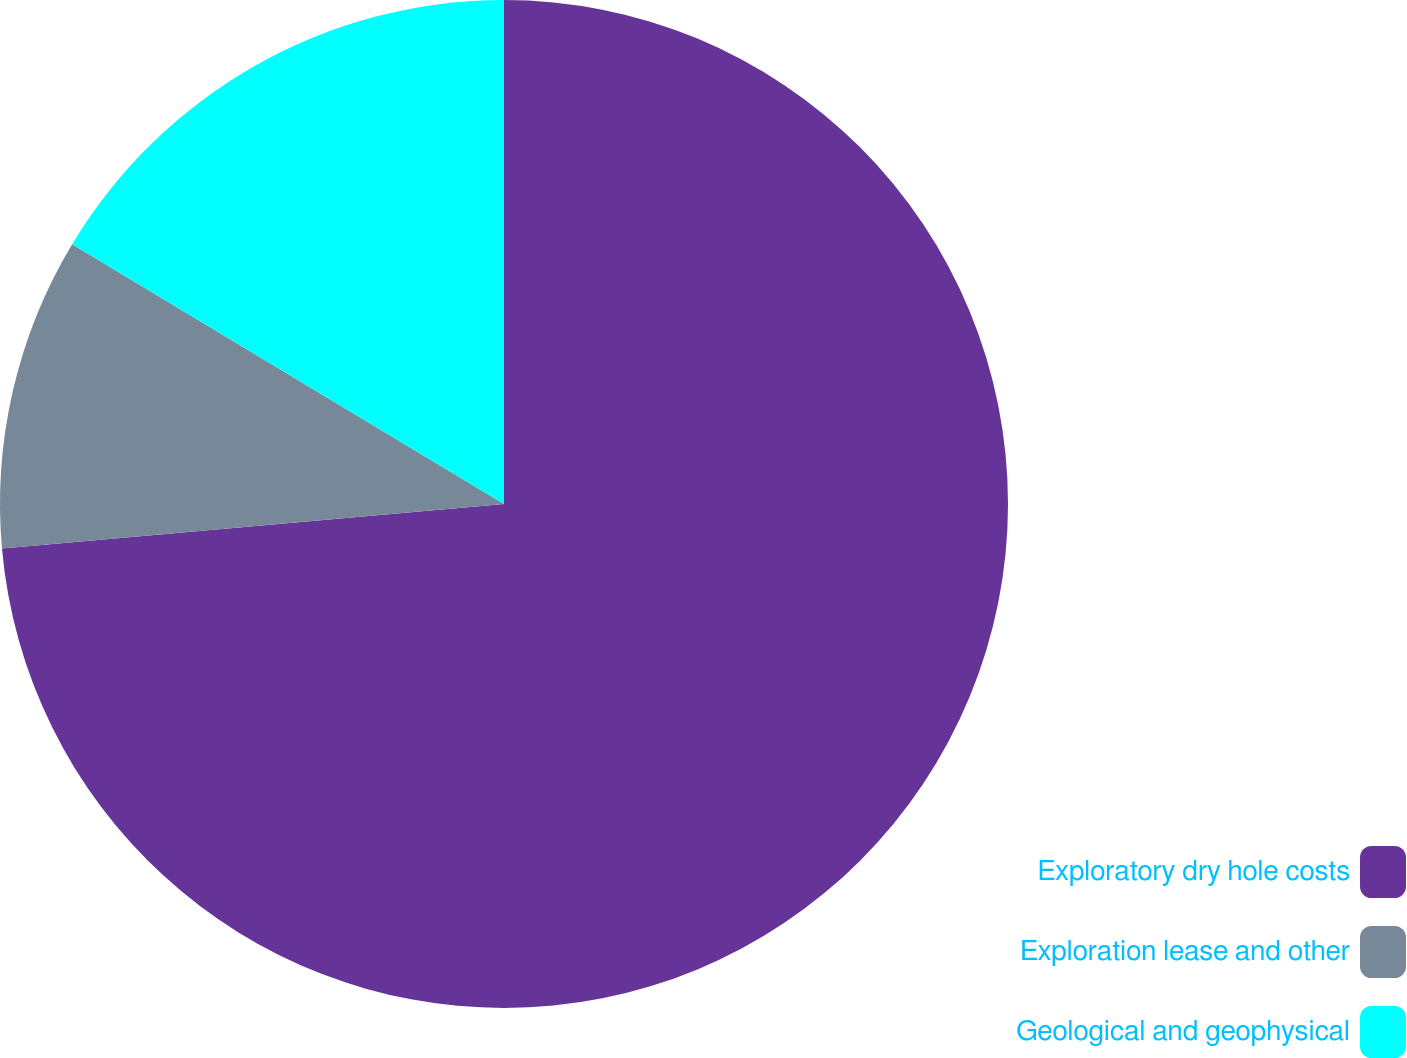Convert chart. <chart><loc_0><loc_0><loc_500><loc_500><pie_chart><fcel>Exploratory dry hole costs<fcel>Exploration lease and other<fcel>Geological and geophysical<nl><fcel>73.59%<fcel>10.03%<fcel>16.38%<nl></chart> 